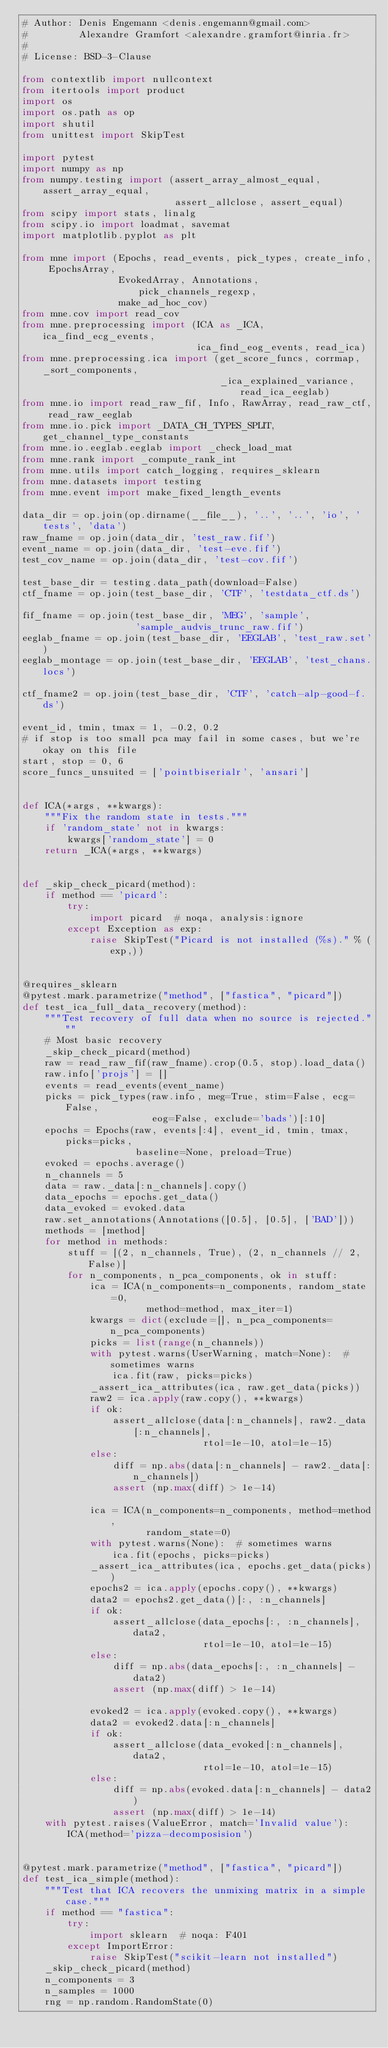Convert code to text. <code><loc_0><loc_0><loc_500><loc_500><_Python_># Author: Denis Engemann <denis.engemann@gmail.com>
#         Alexandre Gramfort <alexandre.gramfort@inria.fr>
#
# License: BSD-3-Clause

from contextlib import nullcontext
from itertools import product
import os
import os.path as op
import shutil
from unittest import SkipTest

import pytest
import numpy as np
from numpy.testing import (assert_array_almost_equal, assert_array_equal,
                           assert_allclose, assert_equal)
from scipy import stats, linalg
from scipy.io import loadmat, savemat
import matplotlib.pyplot as plt

from mne import (Epochs, read_events, pick_types, create_info, EpochsArray,
                 EvokedArray, Annotations, pick_channels_regexp,
                 make_ad_hoc_cov)
from mne.cov import read_cov
from mne.preprocessing import (ICA as _ICA, ica_find_ecg_events,
                               ica_find_eog_events, read_ica)
from mne.preprocessing.ica import (get_score_funcs, corrmap, _sort_components,
                                   _ica_explained_variance, read_ica_eeglab)
from mne.io import read_raw_fif, Info, RawArray, read_raw_ctf, read_raw_eeglab
from mne.io.pick import _DATA_CH_TYPES_SPLIT, get_channel_type_constants
from mne.io.eeglab.eeglab import _check_load_mat
from mne.rank import _compute_rank_int
from mne.utils import catch_logging, requires_sklearn
from mne.datasets import testing
from mne.event import make_fixed_length_events

data_dir = op.join(op.dirname(__file__), '..', '..', 'io', 'tests', 'data')
raw_fname = op.join(data_dir, 'test_raw.fif')
event_name = op.join(data_dir, 'test-eve.fif')
test_cov_name = op.join(data_dir, 'test-cov.fif')

test_base_dir = testing.data_path(download=False)
ctf_fname = op.join(test_base_dir, 'CTF', 'testdata_ctf.ds')

fif_fname = op.join(test_base_dir, 'MEG', 'sample',
                    'sample_audvis_trunc_raw.fif')
eeglab_fname = op.join(test_base_dir, 'EEGLAB', 'test_raw.set')
eeglab_montage = op.join(test_base_dir, 'EEGLAB', 'test_chans.locs')

ctf_fname2 = op.join(test_base_dir, 'CTF', 'catch-alp-good-f.ds')

event_id, tmin, tmax = 1, -0.2, 0.2
# if stop is too small pca may fail in some cases, but we're okay on this file
start, stop = 0, 6
score_funcs_unsuited = ['pointbiserialr', 'ansari']


def ICA(*args, **kwargs):
    """Fix the random state in tests."""
    if 'random_state' not in kwargs:
        kwargs['random_state'] = 0
    return _ICA(*args, **kwargs)


def _skip_check_picard(method):
    if method == 'picard':
        try:
            import picard  # noqa, analysis:ignore
        except Exception as exp:
            raise SkipTest("Picard is not installed (%s)." % (exp,))


@requires_sklearn
@pytest.mark.parametrize("method", ["fastica", "picard"])
def test_ica_full_data_recovery(method):
    """Test recovery of full data when no source is rejected."""
    # Most basic recovery
    _skip_check_picard(method)
    raw = read_raw_fif(raw_fname).crop(0.5, stop).load_data()
    raw.info['projs'] = []
    events = read_events(event_name)
    picks = pick_types(raw.info, meg=True, stim=False, ecg=False,
                       eog=False, exclude='bads')[:10]
    epochs = Epochs(raw, events[:4], event_id, tmin, tmax, picks=picks,
                    baseline=None, preload=True)
    evoked = epochs.average()
    n_channels = 5
    data = raw._data[:n_channels].copy()
    data_epochs = epochs.get_data()
    data_evoked = evoked.data
    raw.set_annotations(Annotations([0.5], [0.5], ['BAD']))
    methods = [method]
    for method in methods:
        stuff = [(2, n_channels, True), (2, n_channels // 2, False)]
        for n_components, n_pca_components, ok in stuff:
            ica = ICA(n_components=n_components, random_state=0,
                      method=method, max_iter=1)
            kwargs = dict(exclude=[], n_pca_components=n_pca_components)
            picks = list(range(n_channels))
            with pytest.warns(UserWarning, match=None):  # sometimes warns
                ica.fit(raw, picks=picks)
            _assert_ica_attributes(ica, raw.get_data(picks))
            raw2 = ica.apply(raw.copy(), **kwargs)
            if ok:
                assert_allclose(data[:n_channels], raw2._data[:n_channels],
                                rtol=1e-10, atol=1e-15)
            else:
                diff = np.abs(data[:n_channels] - raw2._data[:n_channels])
                assert (np.max(diff) > 1e-14)

            ica = ICA(n_components=n_components, method=method,
                      random_state=0)
            with pytest.warns(None):  # sometimes warns
                ica.fit(epochs, picks=picks)
            _assert_ica_attributes(ica, epochs.get_data(picks))
            epochs2 = ica.apply(epochs.copy(), **kwargs)
            data2 = epochs2.get_data()[:, :n_channels]
            if ok:
                assert_allclose(data_epochs[:, :n_channels], data2,
                                rtol=1e-10, atol=1e-15)
            else:
                diff = np.abs(data_epochs[:, :n_channels] - data2)
                assert (np.max(diff) > 1e-14)

            evoked2 = ica.apply(evoked.copy(), **kwargs)
            data2 = evoked2.data[:n_channels]
            if ok:
                assert_allclose(data_evoked[:n_channels], data2,
                                rtol=1e-10, atol=1e-15)
            else:
                diff = np.abs(evoked.data[:n_channels] - data2)
                assert (np.max(diff) > 1e-14)
    with pytest.raises(ValueError, match='Invalid value'):
        ICA(method='pizza-decomposision')


@pytest.mark.parametrize("method", ["fastica", "picard"])
def test_ica_simple(method):
    """Test that ICA recovers the unmixing matrix in a simple case."""
    if method == "fastica":
        try:
            import sklearn  # noqa: F401
        except ImportError:
            raise SkipTest("scikit-learn not installed")
    _skip_check_picard(method)
    n_components = 3
    n_samples = 1000
    rng = np.random.RandomState(0)</code> 